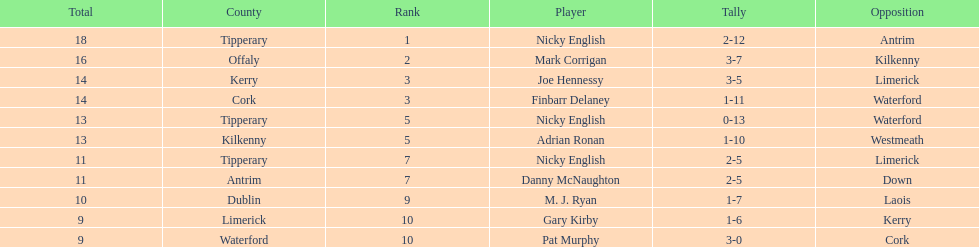If you added all the total's up, what would the number be? 138. Would you be able to parse every entry in this table? {'header': ['Total', 'County', 'Rank', 'Player', 'Tally', 'Opposition'], 'rows': [['18', 'Tipperary', '1', 'Nicky English', '2-12', 'Antrim'], ['16', 'Offaly', '2', 'Mark Corrigan', '3-7', 'Kilkenny'], ['14', 'Kerry', '3', 'Joe Hennessy', '3-5', 'Limerick'], ['14', 'Cork', '3', 'Finbarr Delaney', '1-11', 'Waterford'], ['13', 'Tipperary', '5', 'Nicky English', '0-13', 'Waterford'], ['13', 'Kilkenny', '5', 'Adrian Ronan', '1-10', 'Westmeath'], ['11', 'Tipperary', '7', 'Nicky English', '2-5', 'Limerick'], ['11', 'Antrim', '7', 'Danny McNaughton', '2-5', 'Down'], ['10', 'Dublin', '9', 'M. J. Ryan', '1-7', 'Laois'], ['9', 'Limerick', '10', 'Gary Kirby', '1-6', 'Kerry'], ['9', 'Waterford', '10', 'Pat Murphy', '3-0', 'Cork']]} 